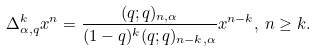<formula> <loc_0><loc_0><loc_500><loc_500>\Delta _ { \alpha , q } ^ { k } x ^ { n } = \frac { ( q ; q ) _ { n , \alpha } } { ( 1 - q ) ^ { k } ( q ; q ) _ { n - k , \alpha } } x ^ { n - k } , \, n \geq k .</formula> 